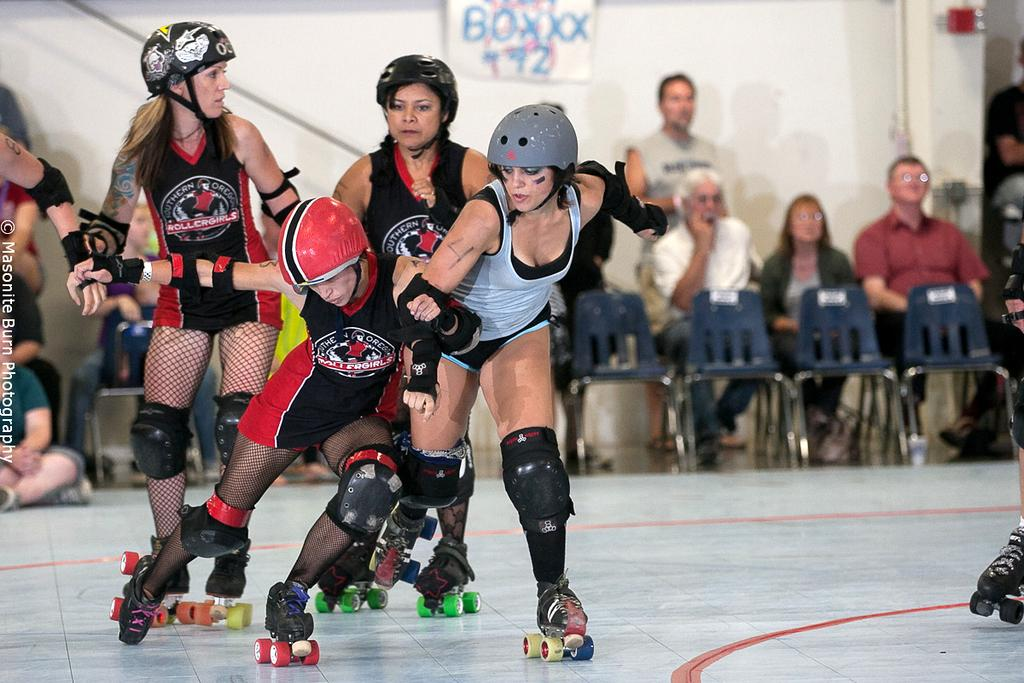What are the people in the image doing? The people in the image are skating on the ground. What safety precaution are the skaters taking? The people skating are wearing helmets. Can you describe the background of the image? In the background, there is a group of people, chairs, a wall, a poster, and other objects. How many people can be seen in the background? There is a group of people in the background, but the exact number is not specified. What type of objects are visible in the background? Chairs, a wall, a poster, and other objects are visible in the background. Can you tell me how many goldfish are swimming in the poster in the image? There are no goldfish present in the image, and therefore no such activity can be observed. What type of error is depicted in the poster in the image? There is no error depicted in the poster in the image; it features a different subject. 